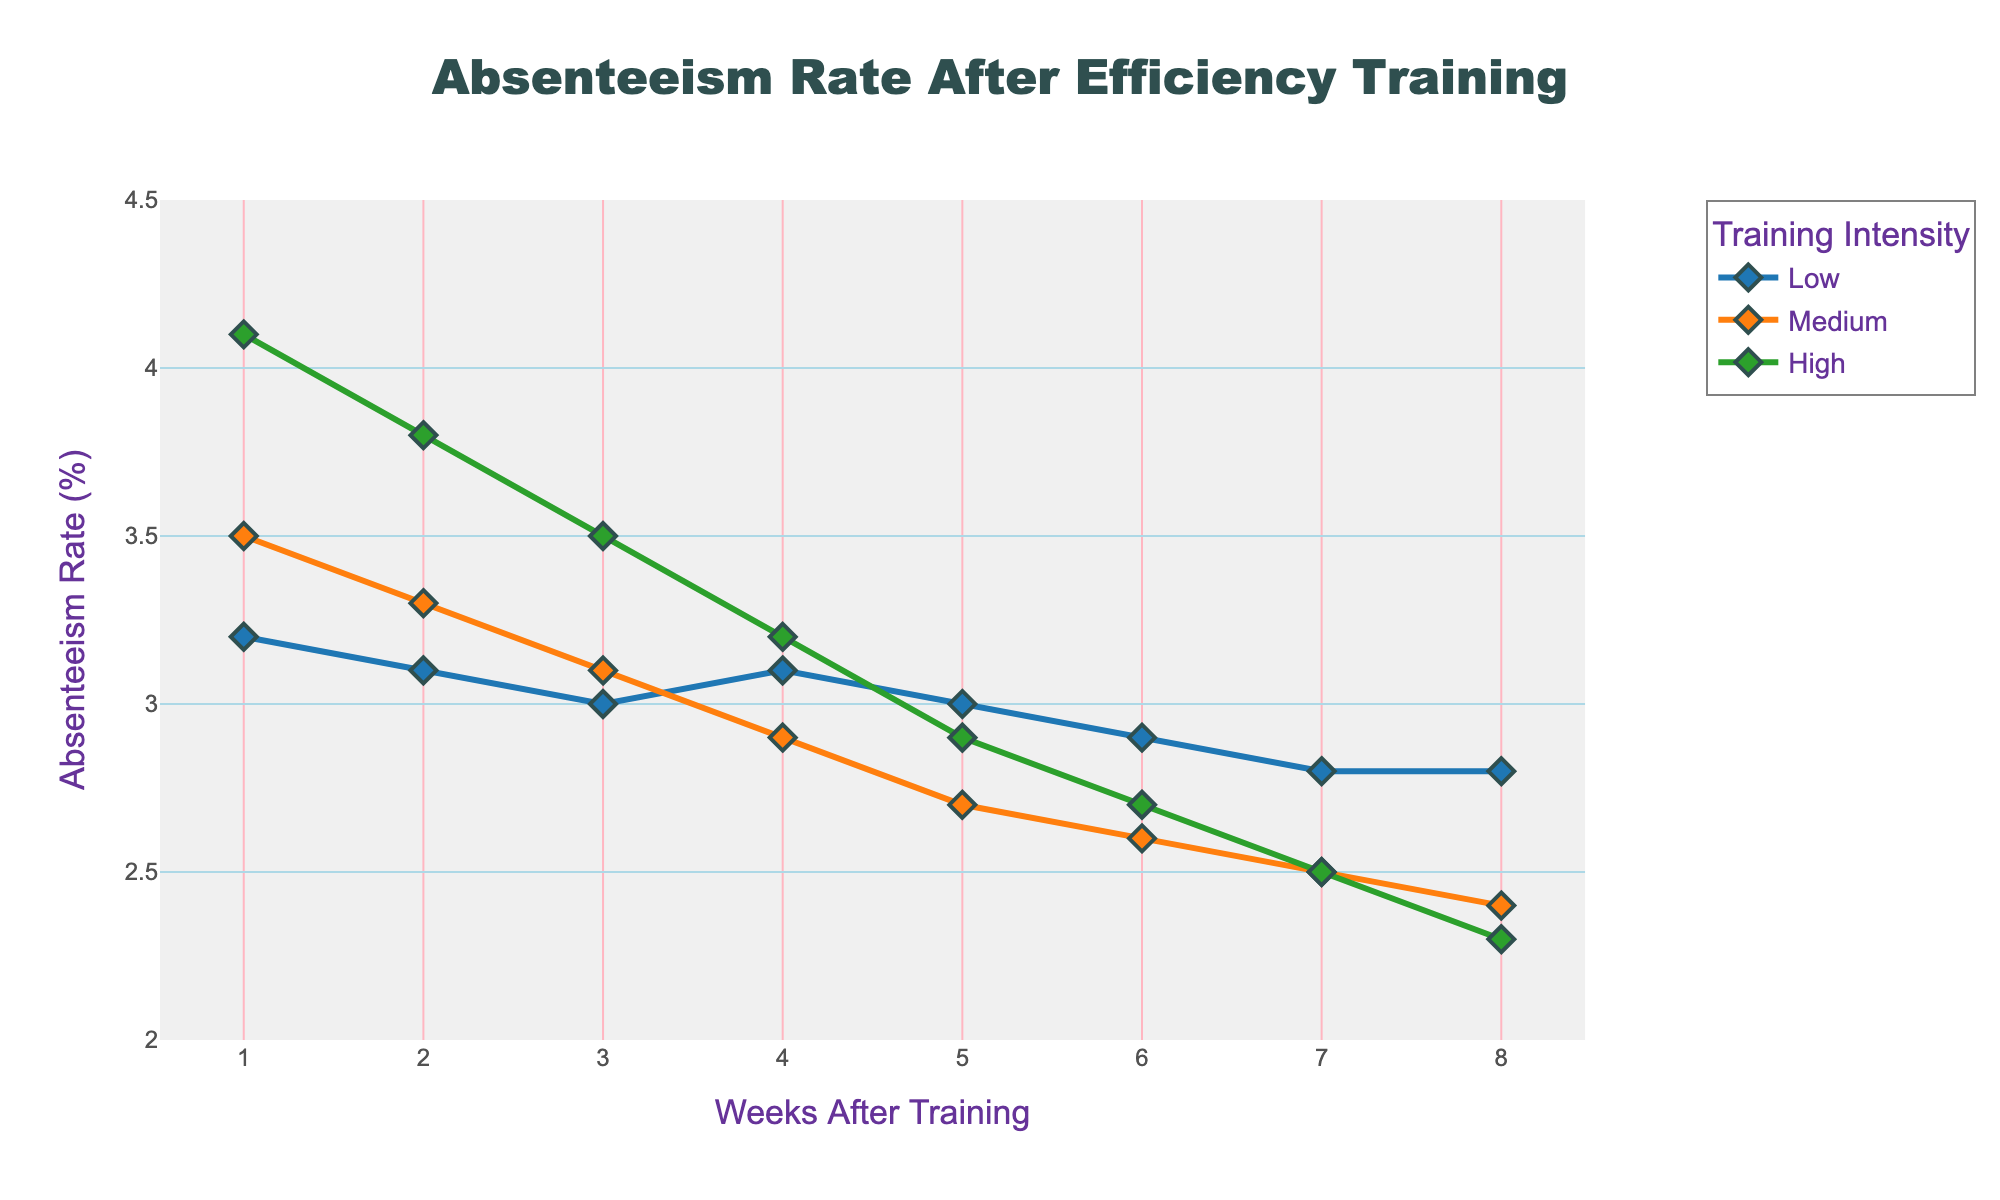What is the absenteeism rate for medium intensity training at week 4? Locate the "Medium" training intensity (usually in orange) and follow to week 4 on the x-axis. The absenteeism rate is positioned on the y-axis.
Answer: 2.9 What is the trend in absenteeism rates for high intensity training from week 1 to week 8? Observe the line representing "High" training intensity (usually in green) and track its movement from week 1 to week 8. The trend shows a consistent decline over the weeks.
Answer: Decreasing How much did the absenteeism rate decrease for low intensity training from week 1 to week 8? Check the "Low" intensity absenteeism rate at week 1 (3.2) and at week 8 (2.8). Subtract the week 8 rate from the week 1 rate (3.2 - 2.8).
Answer: 0.4 Which training intensity showed the greatest improvement (i.e., decrease) in absenteeism rates by week 8? Compare the absenteeism decrease for each intensity from week 1 to week 8: Low: (3.2 to 2.8, 0.4 decrease), Medium: (3.5 to 2.4, 1.1 decrease), High: (4.1 to 2.3, 1.8 decrease). The "High" intensity showed the greatest decrease.
Answer: High At which week does the absenteeism rate for medium intensity training fall below 3.0? Follow the "Medium" intensity line and find the point where it crosses below the 3.0 mark on the y-axis, which happens between week 3 and week 4.
Answer: Week 4 Compare the absenteeism rates for all three intensities at week 5. Which one is the lowest? Look at week 5 on the x-axis and compare the absenteeism rates for "Low" (3.0), "Medium" (2.7), and "High" (2.9) intensities.
Answer: Medium What is the average absenteeism rate for high intensity training over the 8 weeks? Add the rates for "High" intensity (4.1, 3.8, 3.5, 3.2, 2.9, 2.7, 2.5, 2.3) and divide by 8. (4.1 + 3.8 + 3.5 + 3.2 + 2.9 + 2.7 + 2.5 + 2.3) / 8 = 3.125
Answer: 3.125 Does any training intensity show an increase in absenteeism rate at any point? Observe each line. All three lines show a decrease or remain stable, with no noticeable increases in absenteeism rates at any point.
Answer: No 